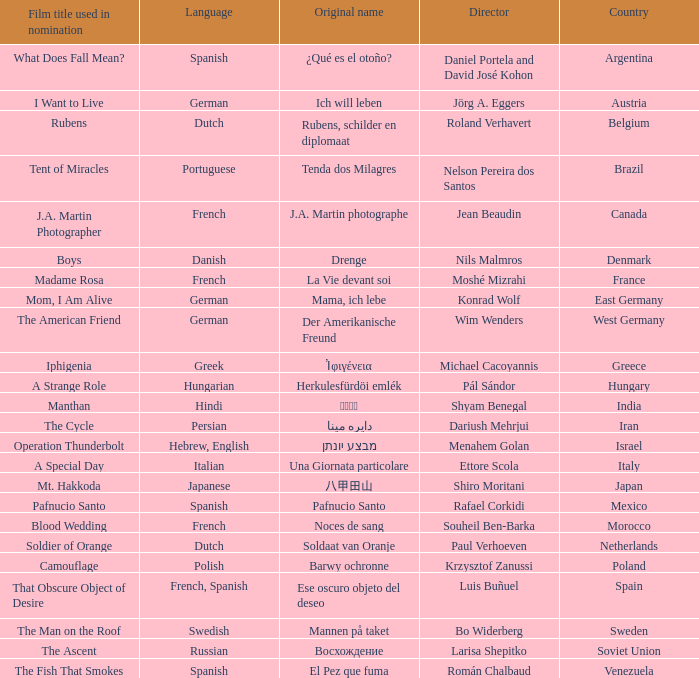Which country is the director Roland Verhavert from? Belgium. 